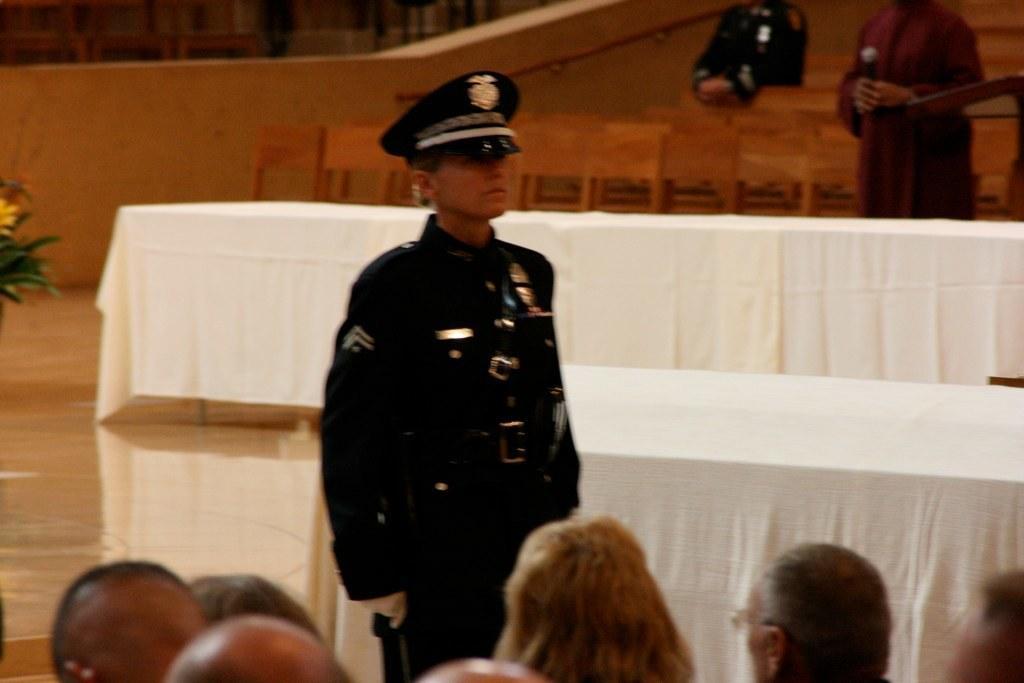In one or two sentences, can you explain what this image depicts? In the center of the image there is a person standing in a uniform. At the bottom of the image there are people. In the background of the image there are chairs. 